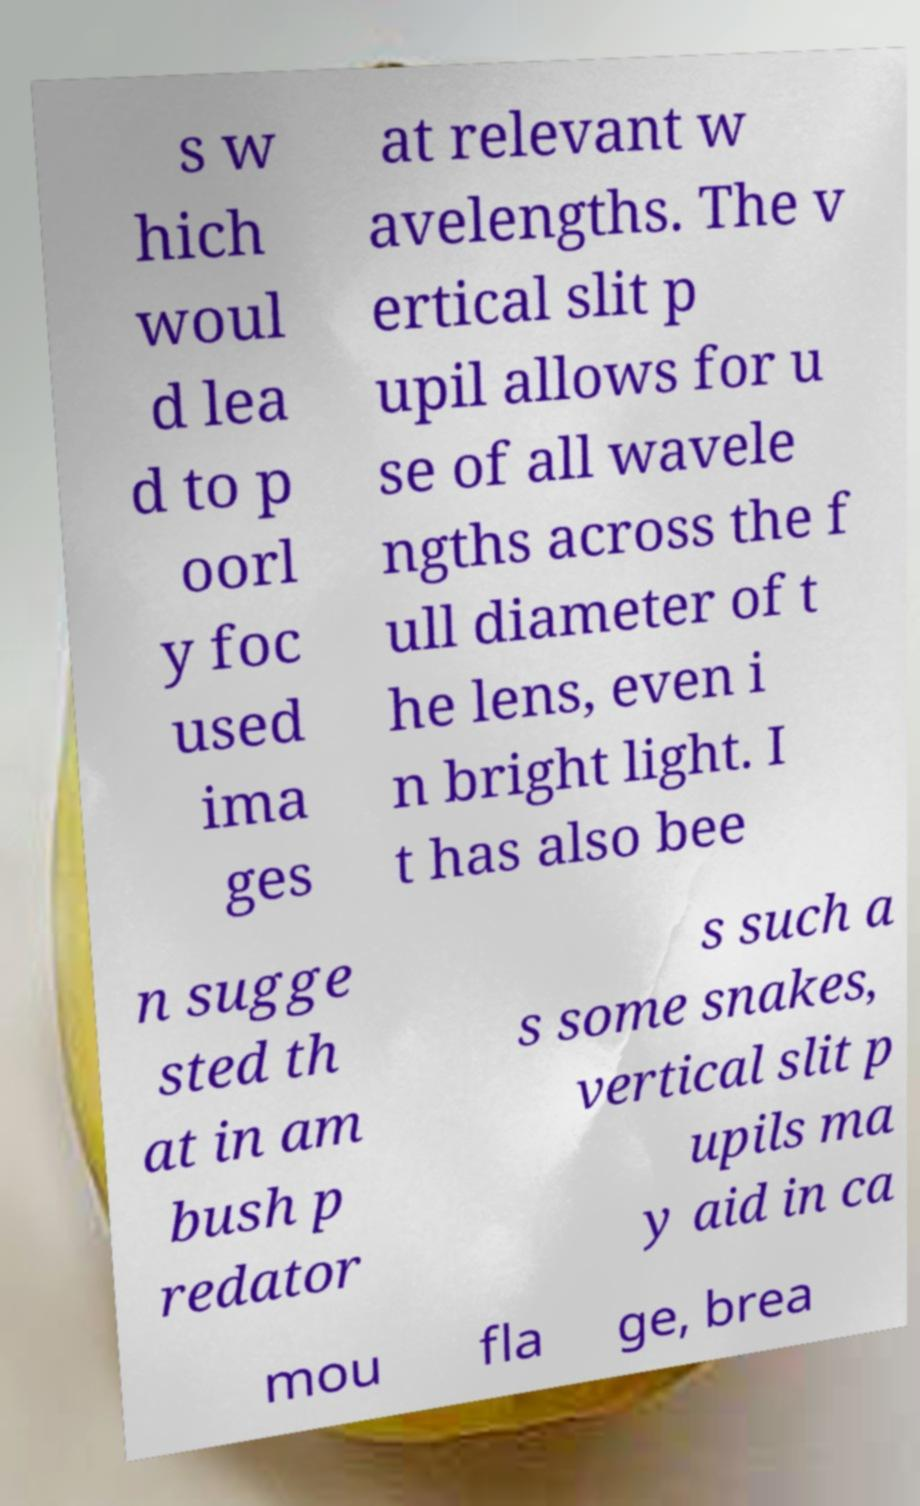Can you read and provide the text displayed in the image?This photo seems to have some interesting text. Can you extract and type it out for me? s w hich woul d lea d to p oorl y foc used ima ges at relevant w avelengths. The v ertical slit p upil allows for u se of all wavele ngths across the f ull diameter of t he lens, even i n bright light. I t has also bee n sugge sted th at in am bush p redator s such a s some snakes, vertical slit p upils ma y aid in ca mou fla ge, brea 